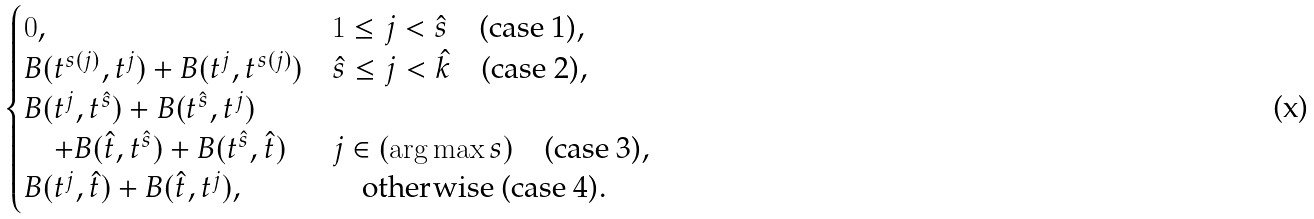<formula> <loc_0><loc_0><loc_500><loc_500>\begin{cases} 0 , & 1 \leq j < \hat { s } \quad \text {(case 1)} , \\ B ( t ^ { s ( j ) } , t ^ { j } ) + B ( t ^ { j } , t ^ { s ( j ) } ) & \hat { s } \leq j < \hat { k } \quad \text {(case 2)} , \\ B ( t ^ { j } , t ^ { \hat { s } } ) + B ( t ^ { \hat { s } } , t ^ { j } ) \\ \quad + B ( \hat { t } , t ^ { \hat { s } } ) + B ( t ^ { \hat { s } } , \hat { t } ) & j \in ( \arg \max s ) \quad \text {(case 3)} , \\ B ( t ^ { j } , \hat { t } ) + B ( \hat { t } , t ^ { j } ) , & \quad \text {otherwise (case 4)} . \end{cases}</formula> 